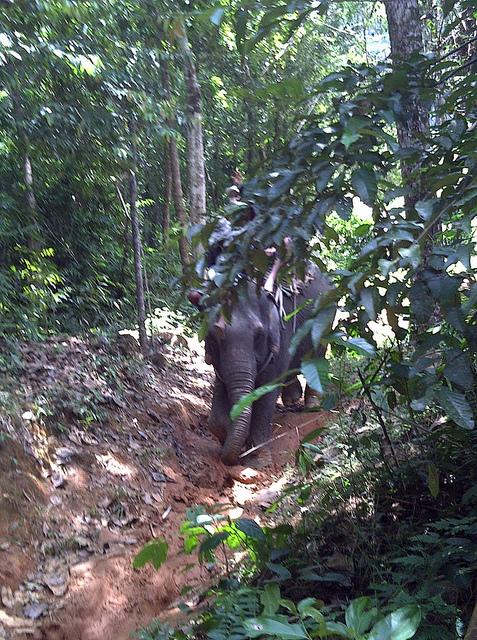Can you see a car in the picture?
Short answer required. No. Is everyone in the picture on the elephant?
Concise answer only. Yes. What animal is in the picture?
Quick response, please. Elephant. Are the leaves green?
Write a very short answer. Yes. Why is there a track between the rows?
Keep it brief. Walking. Which animal is walking on the wood?
Short answer required. Elephant. What animal is in the background?
Quick response, please. Elephant. What is growing?
Quick response, please. Trees. Was this picture taken in the wild?
Short answer required. Yes. 